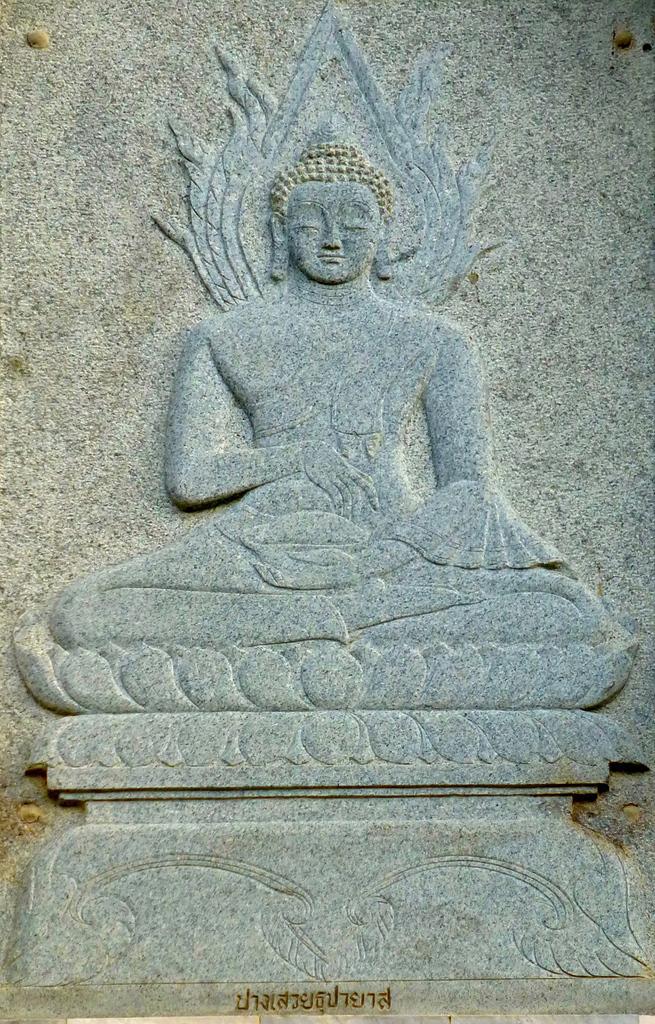In one or two sentences, can you explain what this image depicts? In this picture I can see the statue of a person on a granite stone. At the bottom there is something is written on the stone. 